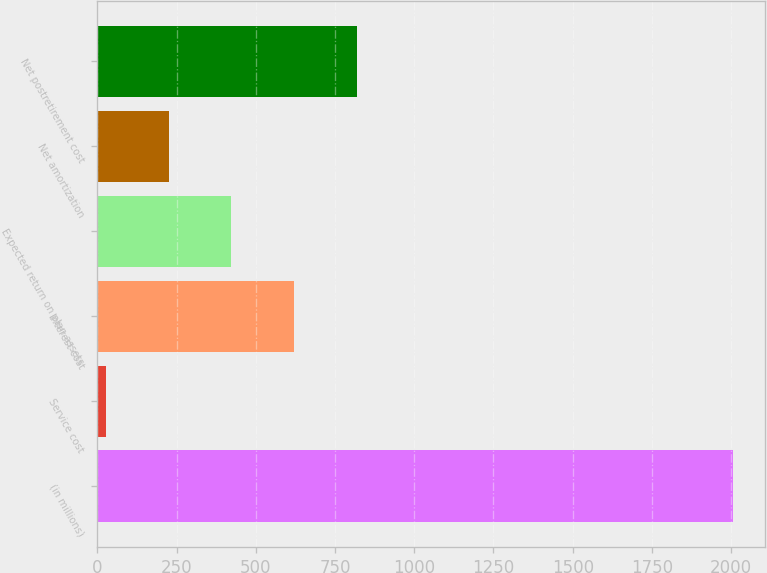<chart> <loc_0><loc_0><loc_500><loc_500><bar_chart><fcel>(in millions)<fcel>Service cost<fcel>Interest cost<fcel>Expected return on plan assets<fcel>Net amortization<fcel>Net postretirement cost<nl><fcel>2007<fcel>27<fcel>621<fcel>423<fcel>225<fcel>819<nl></chart> 